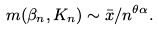<formula> <loc_0><loc_0><loc_500><loc_500>m ( \beta _ { n } , K _ { n } ) \sim \bar { x } / n ^ { \theta \alpha } .</formula> 